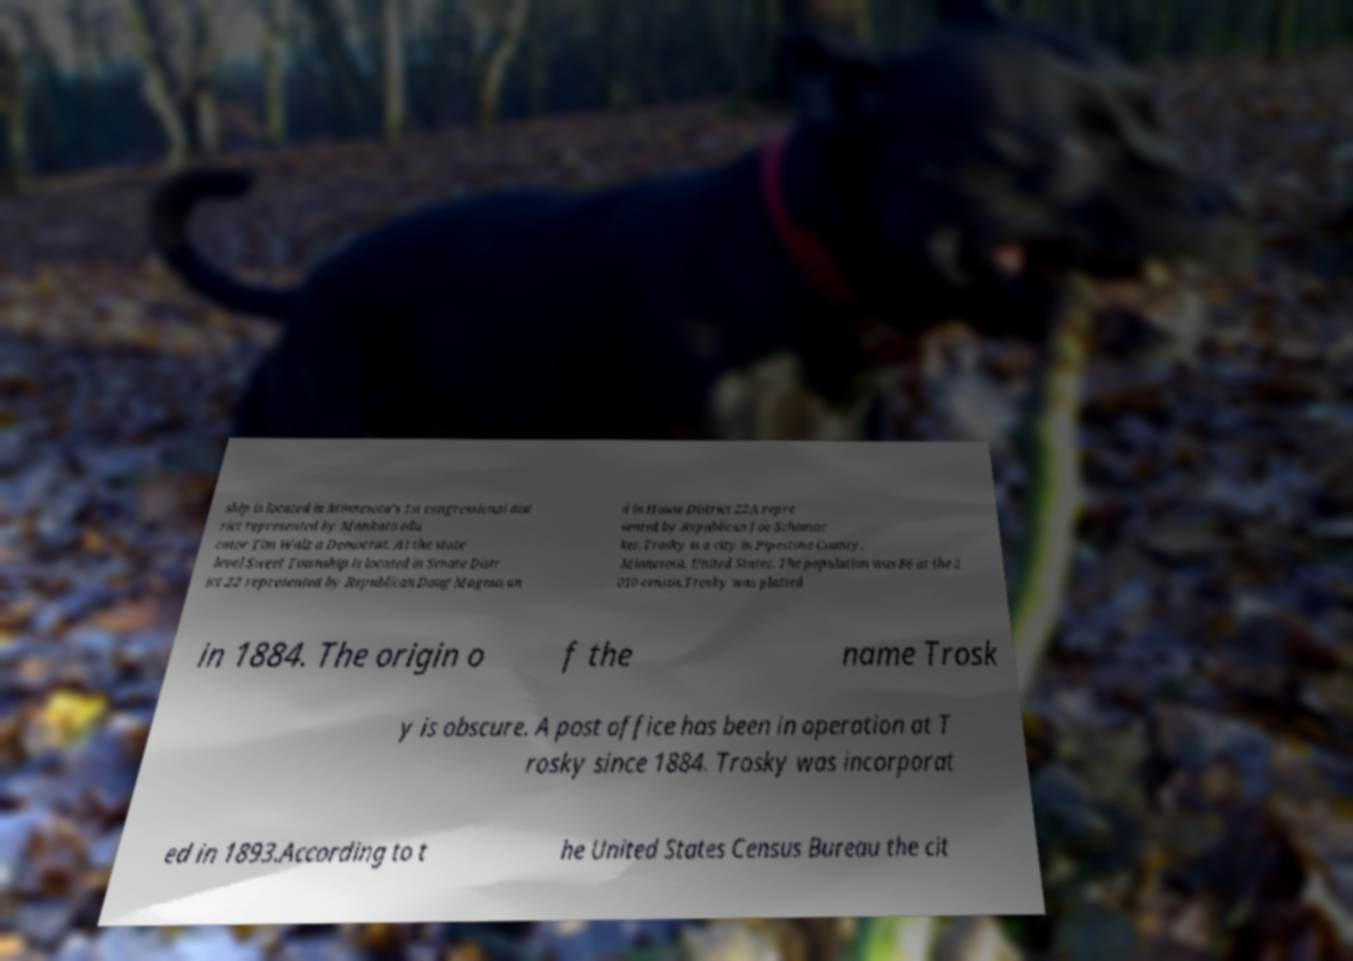Could you assist in decoding the text presented in this image and type it out clearly? ship is located in Minnesota's 1st congressional dist rict represented by Mankato edu cator Tim Walz a Democrat. At the state level Sweet Township is located in Senate Distr ict 22 represented by Republican Doug Magnus an d in House District 22A repre sented by Republican Joe Schomac ker.Trosky is a city in Pipestone County, Minnesota, United States. The population was 86 at the 2 010 census.Trosky was platted in 1884. The origin o f the name Trosk y is obscure. A post office has been in operation at T rosky since 1884. Trosky was incorporat ed in 1893.According to t he United States Census Bureau the cit 